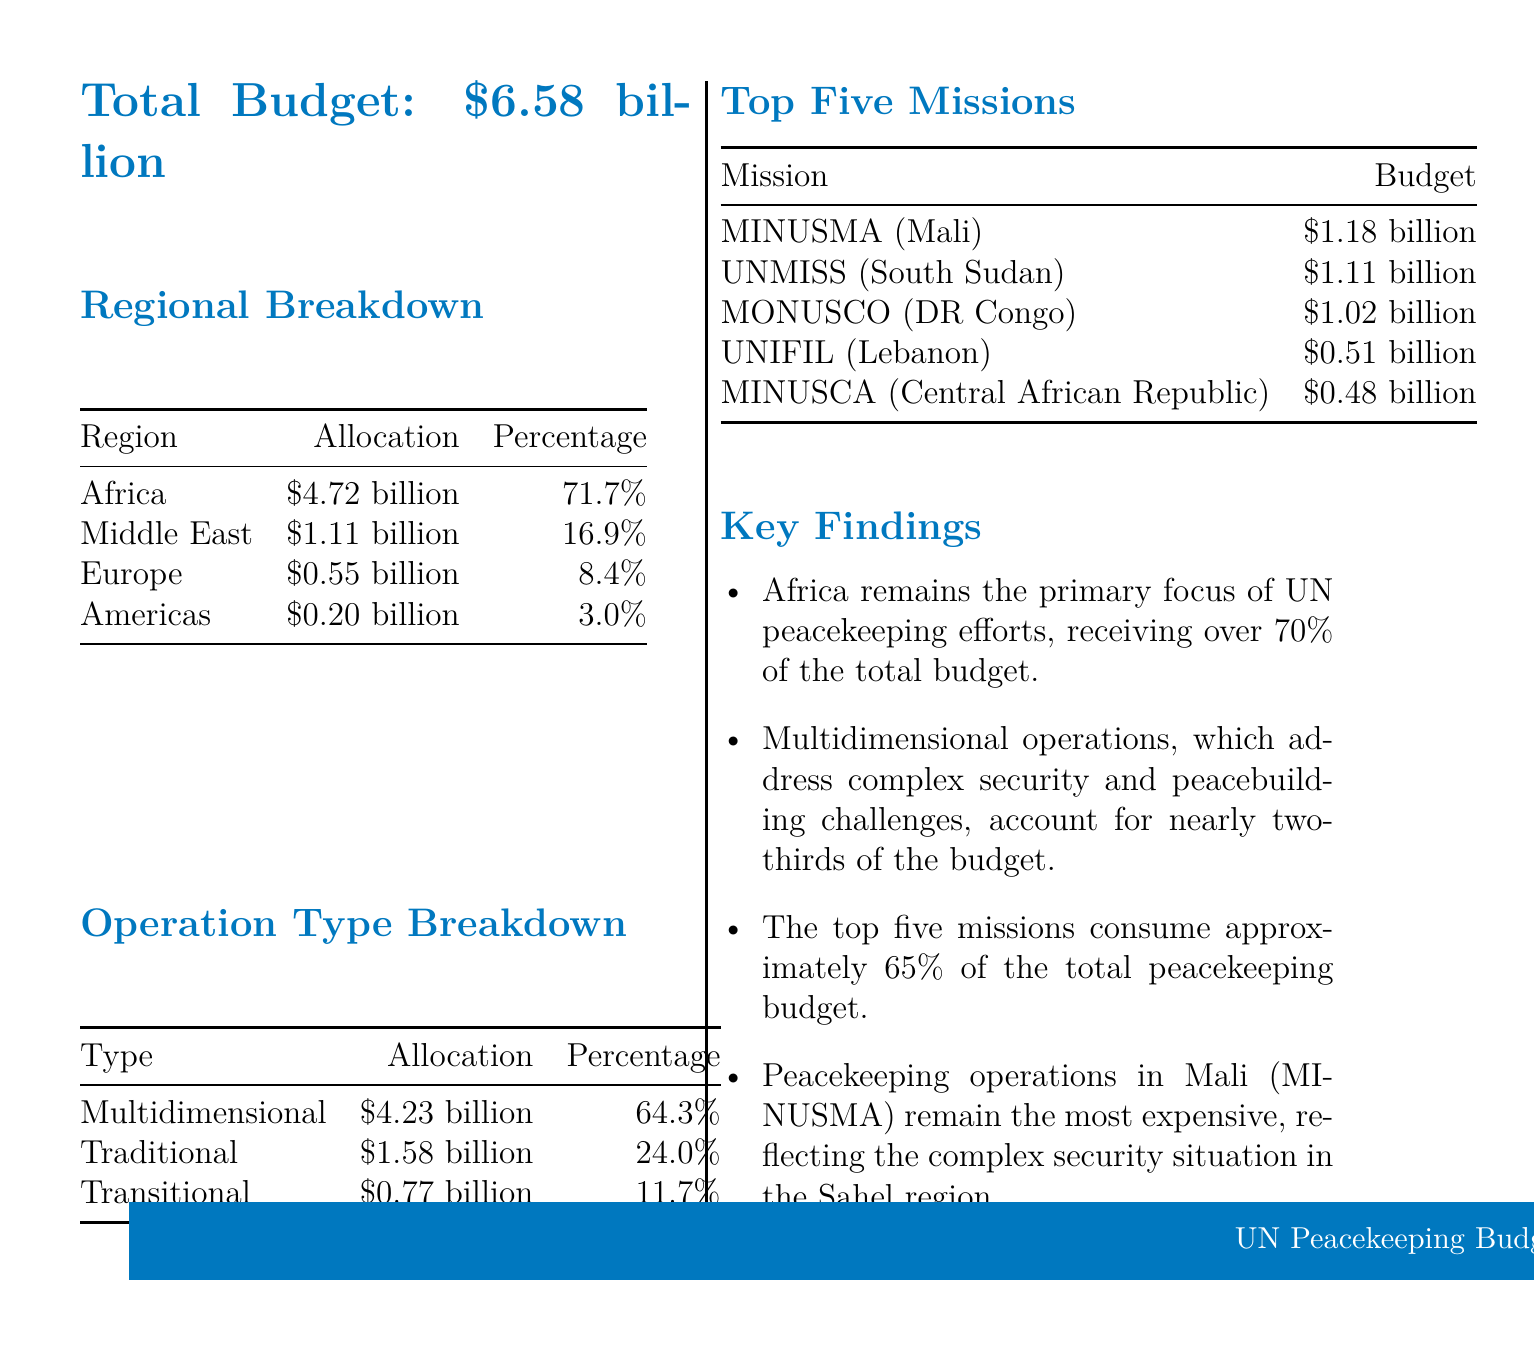what is the total budget for UN peacekeeping missions? The total budget for UN peacekeeping missions for the fiscal year 2022-2023 is stated as $6.58 billion.
Answer: $6.58 billion which region has the highest budget allocation? The document provides a regional breakdown of the budget, highlighting that Africa has the highest allocation of $4.72 billion.
Answer: Africa what percentage of the budget is allocated to multidimensional operations? The operation type breakdown indicates that multidimensional operations receive 64.3% of the total budget.
Answer: 64.3% how much budget is allocated for the UNMISS mission in South Sudan? The top five missions section lists the budget for UNMISS (South Sudan) as $1.11 billion.
Answer: $1.11 billion what is the total percentage of budget allocated to Europe and the Americas combined? By adding the percentages for Europe (8.4%) and the Americas (3.0%), we can calculate that the combined percentage is 11.4%.
Answer: 11.4% which operation type accounts for the smallest budget allocation? The operation type breakdown shows that transitional operations have the smallest allocation at $0.77 billion.
Answer: Transitional what does the key finding highlight about operations in Mali? The key findings mention that peacekeeping operations in Mali (MINUSMA) are the most expensive, reflecting a complex security situation.
Answer: Most expensive how much of the total peacekeeping budget do the top five missions consume? The key findings indicate that the top five missions consume approximately 65% of the total budget.
Answer: 65% 